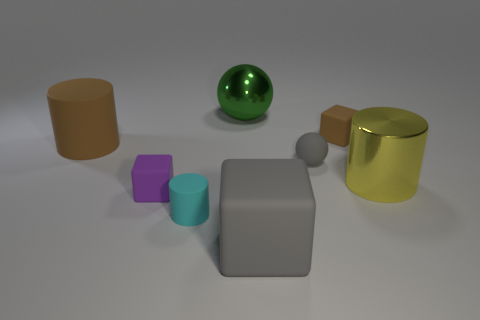Add 2 tiny rubber cubes. How many objects exist? 10 Subtract all cubes. How many objects are left? 5 Add 6 tiny cyan cylinders. How many tiny cyan cylinders exist? 7 Subtract 0 green cylinders. How many objects are left? 8 Subtract all tiny rubber things. Subtract all big green balls. How many objects are left? 3 Add 6 cyan things. How many cyan things are left? 7 